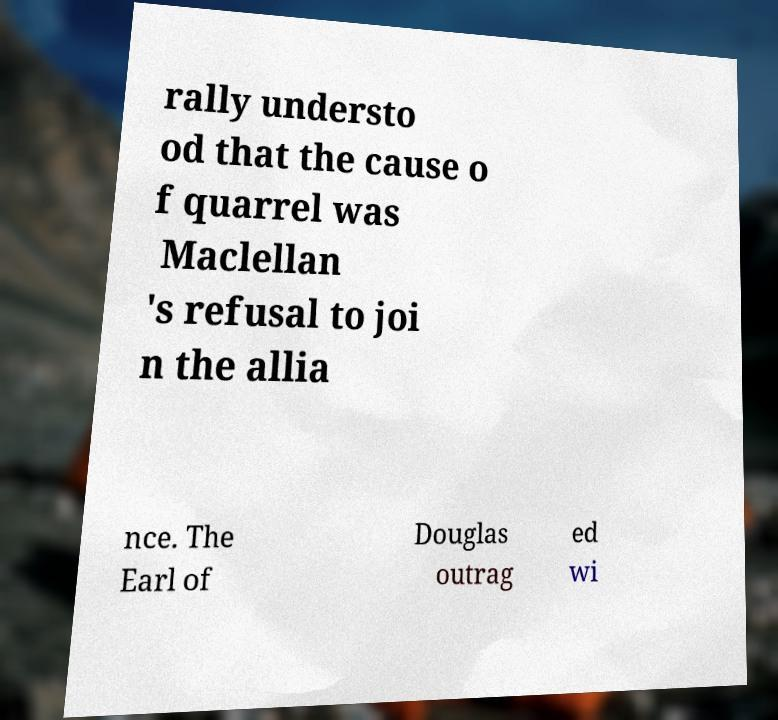There's text embedded in this image that I need extracted. Can you transcribe it verbatim? rally understo od that the cause o f quarrel was Maclellan 's refusal to joi n the allia nce. The Earl of Douglas outrag ed wi 